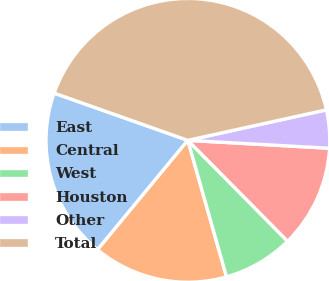Convert chart to OTSL. <chart><loc_0><loc_0><loc_500><loc_500><pie_chart><fcel>East<fcel>Central<fcel>West<fcel>Houston<fcel>Other<fcel>Total<nl><fcel>19.42%<fcel>15.38%<fcel>8.02%<fcel>11.7%<fcel>4.34%<fcel>41.15%<nl></chart> 